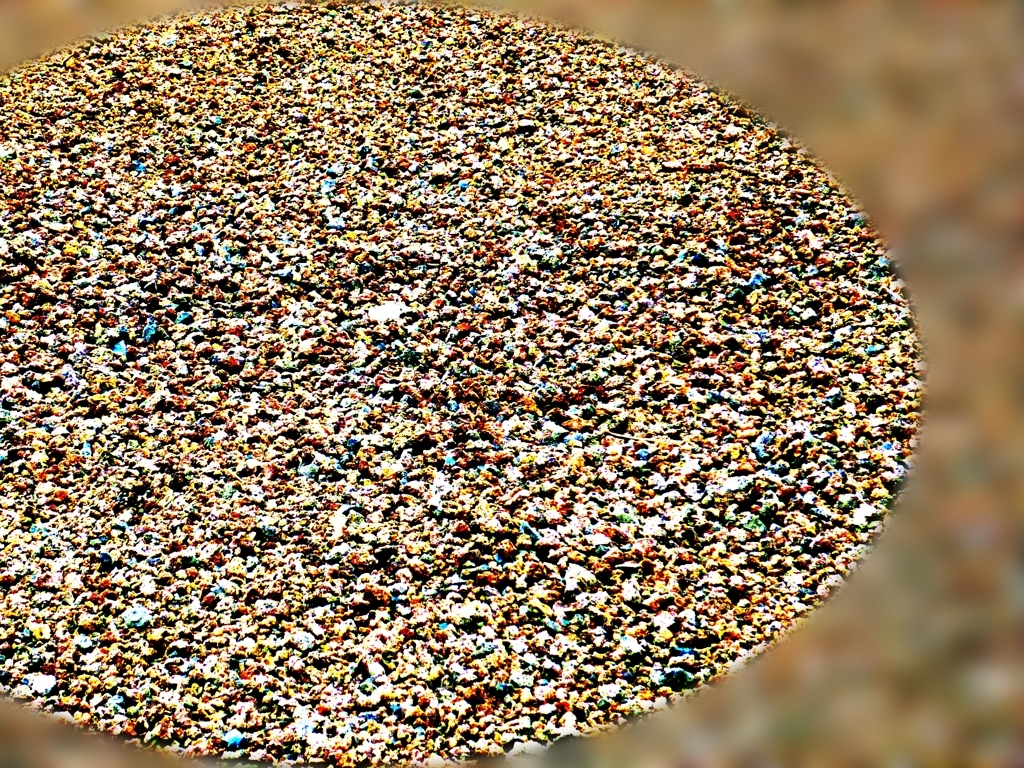Are the colors dull? The colors in the image are not dull; they appear vibrant and varied, with a mix of warm and cool tones that provide a lively visual composition. 